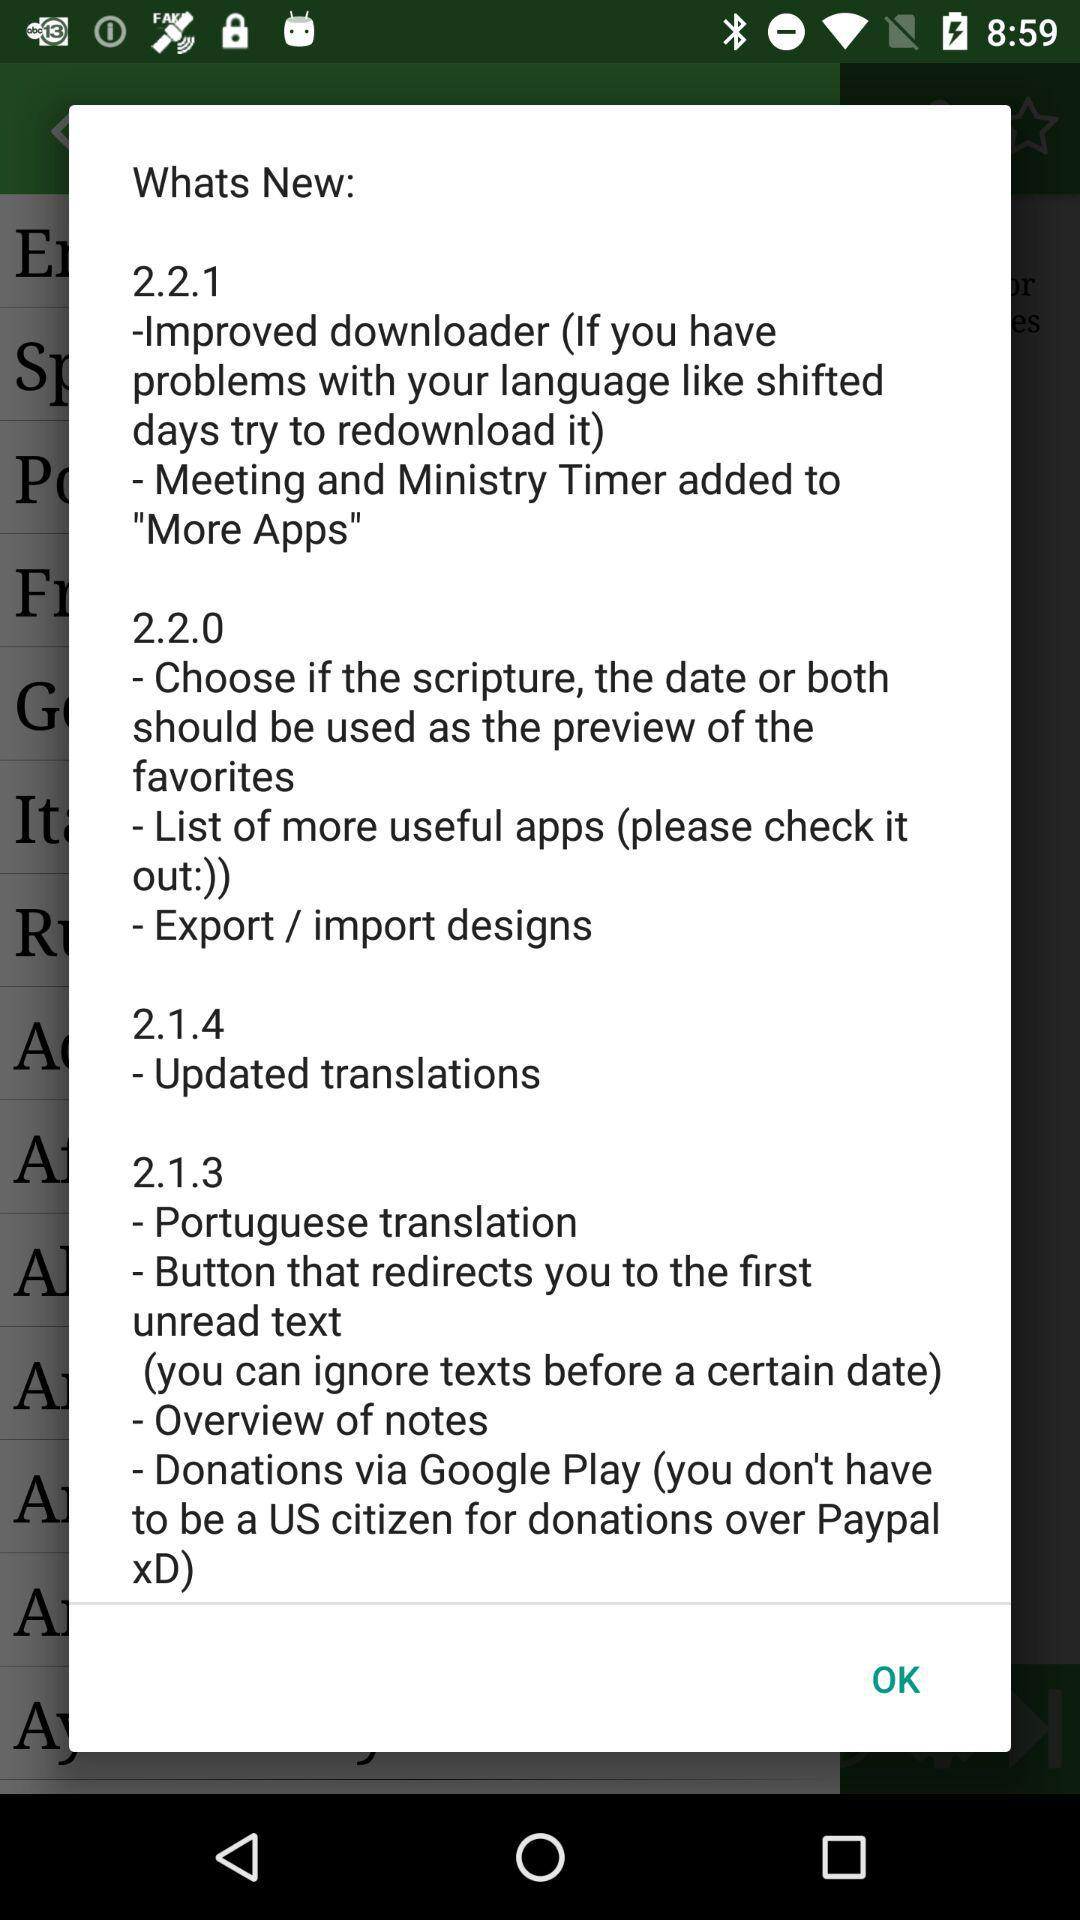What are the updates in version 2.1.4? The update in version 2.1.4 is "Updated translations". 